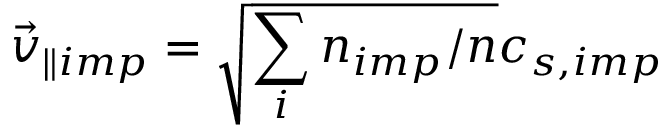Convert formula to latex. <formula><loc_0><loc_0><loc_500><loc_500>\vec { v } _ { \| i m p } = \sqrt { \sum _ { i } n _ { i m p } / n } c _ { s , i m p }</formula> 